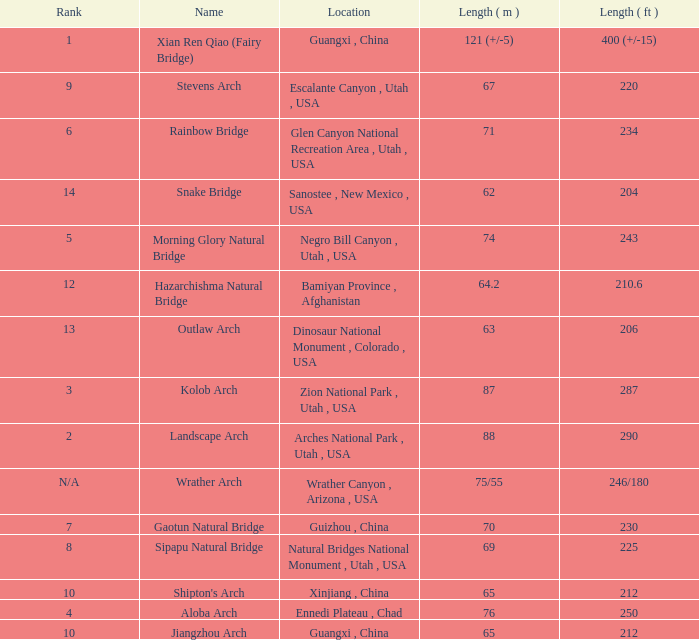What is the rank of the arch with a length in meters of 75/55? N/A. 